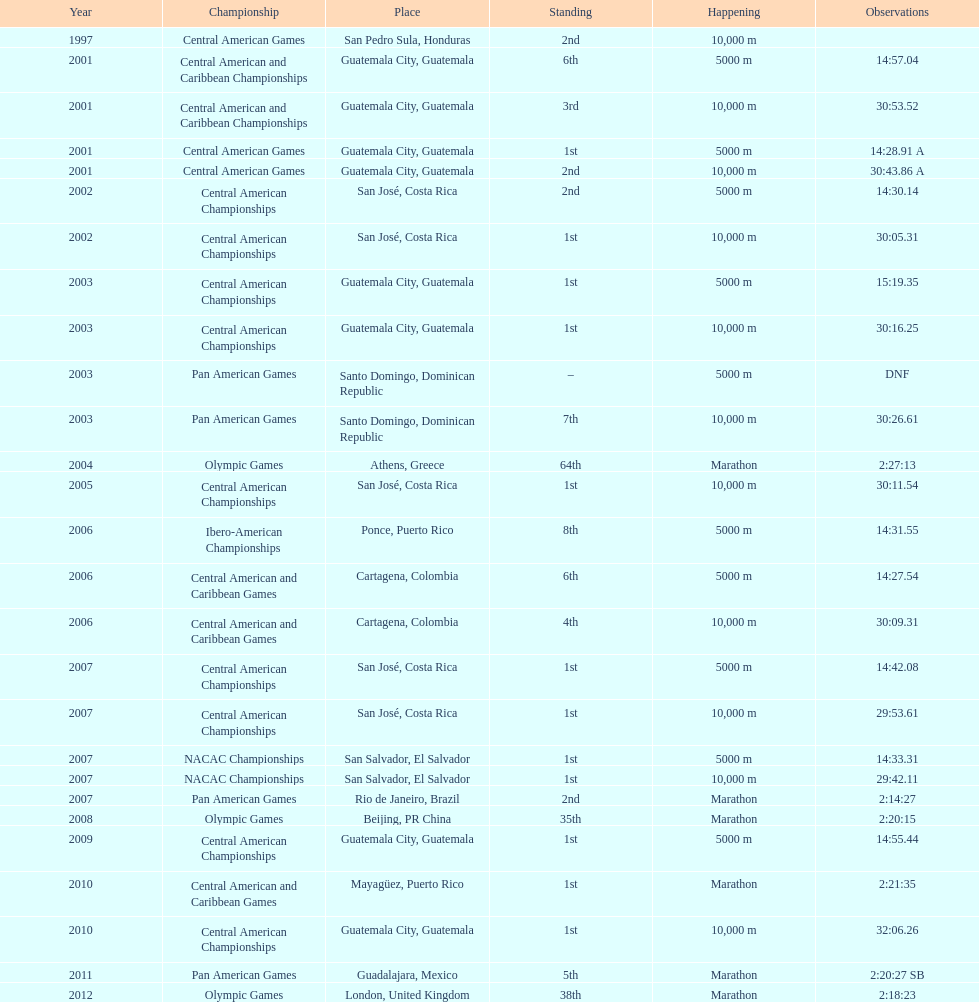Which event is listed more between the 10,000m and the 5000m? 10,000 m. 